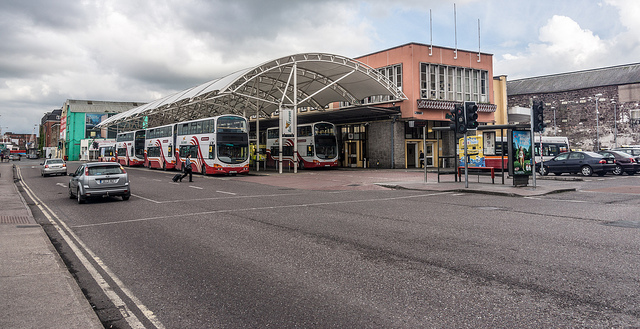How busy does the bus station appear and what does this suggest about the area? The bus station appears moderately busy with several buses parked and few pedestrians visible, suggesting it's a working day with routine activity. This activity level indicates the station's pivotal role in local commuting, hinting that the surrounding area likely has a steady flow of traffic and possibly serves as a commercial or business district. 